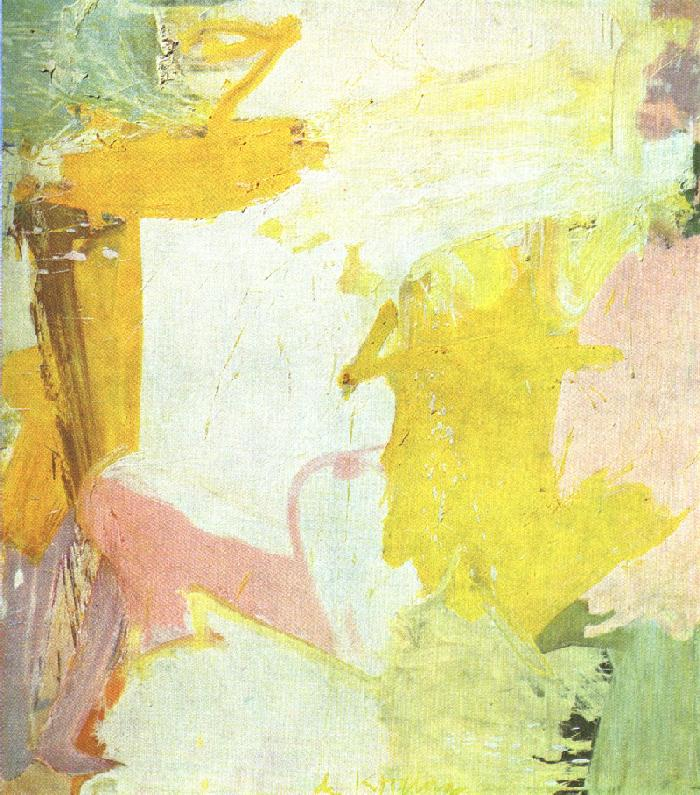Create a haiku inspired by this painting. Pastel dreams unfold,
Whispers of light, calm embrace.
Colors dance like dawn. 